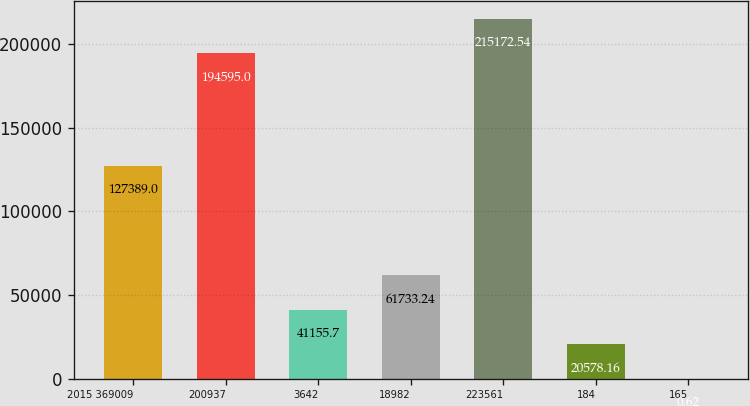Convert chart. <chart><loc_0><loc_0><loc_500><loc_500><bar_chart><fcel>2015 369009<fcel>200937<fcel>3642<fcel>18982<fcel>223561<fcel>184<fcel>165<nl><fcel>127389<fcel>194595<fcel>41155.7<fcel>61733.2<fcel>215173<fcel>20578.2<fcel>0.62<nl></chart> 